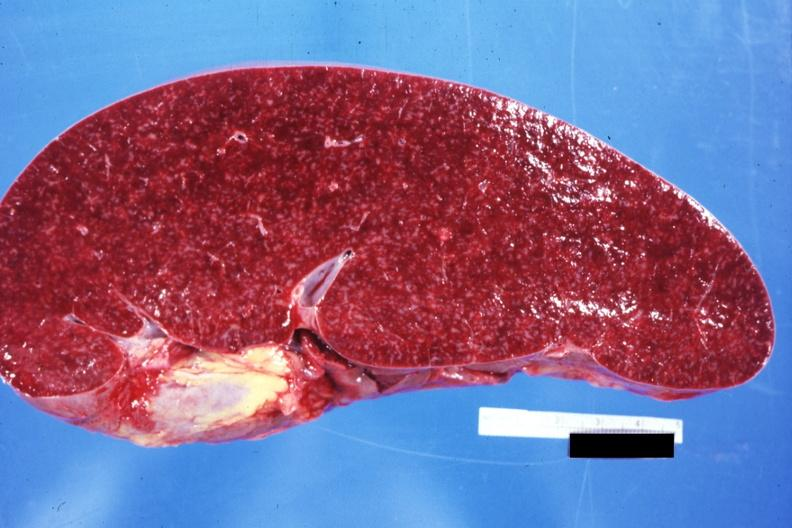s myocardium present?
Answer the question using a single word or phrase. No 